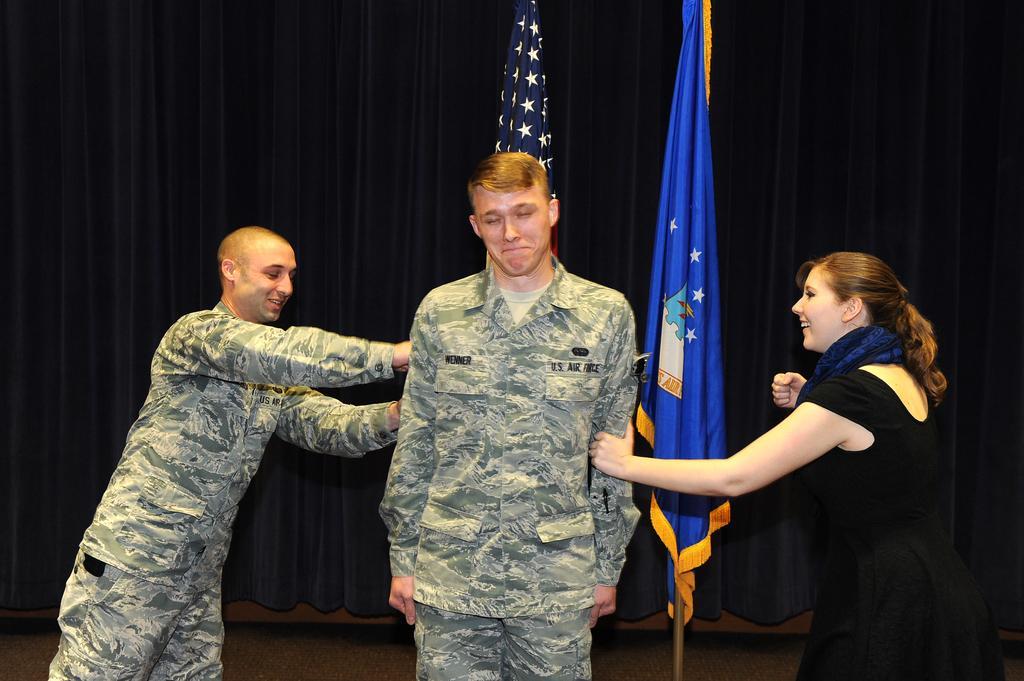Please provide a concise description of this image. In the middle of the picture, we see a man in the uniform is standing and he is smiling. On the left side, we see a man in the uniform is standing and he is smiling. He is trying to hold the hands of the man. On the right side, we see a woman in the black dress is standing and she is smiling. She is holding the hand of the man. Behind him, we see the flag poles and the flags in white, blue and yellow color. In the background, we see a curtain or a sheet in blue color. 